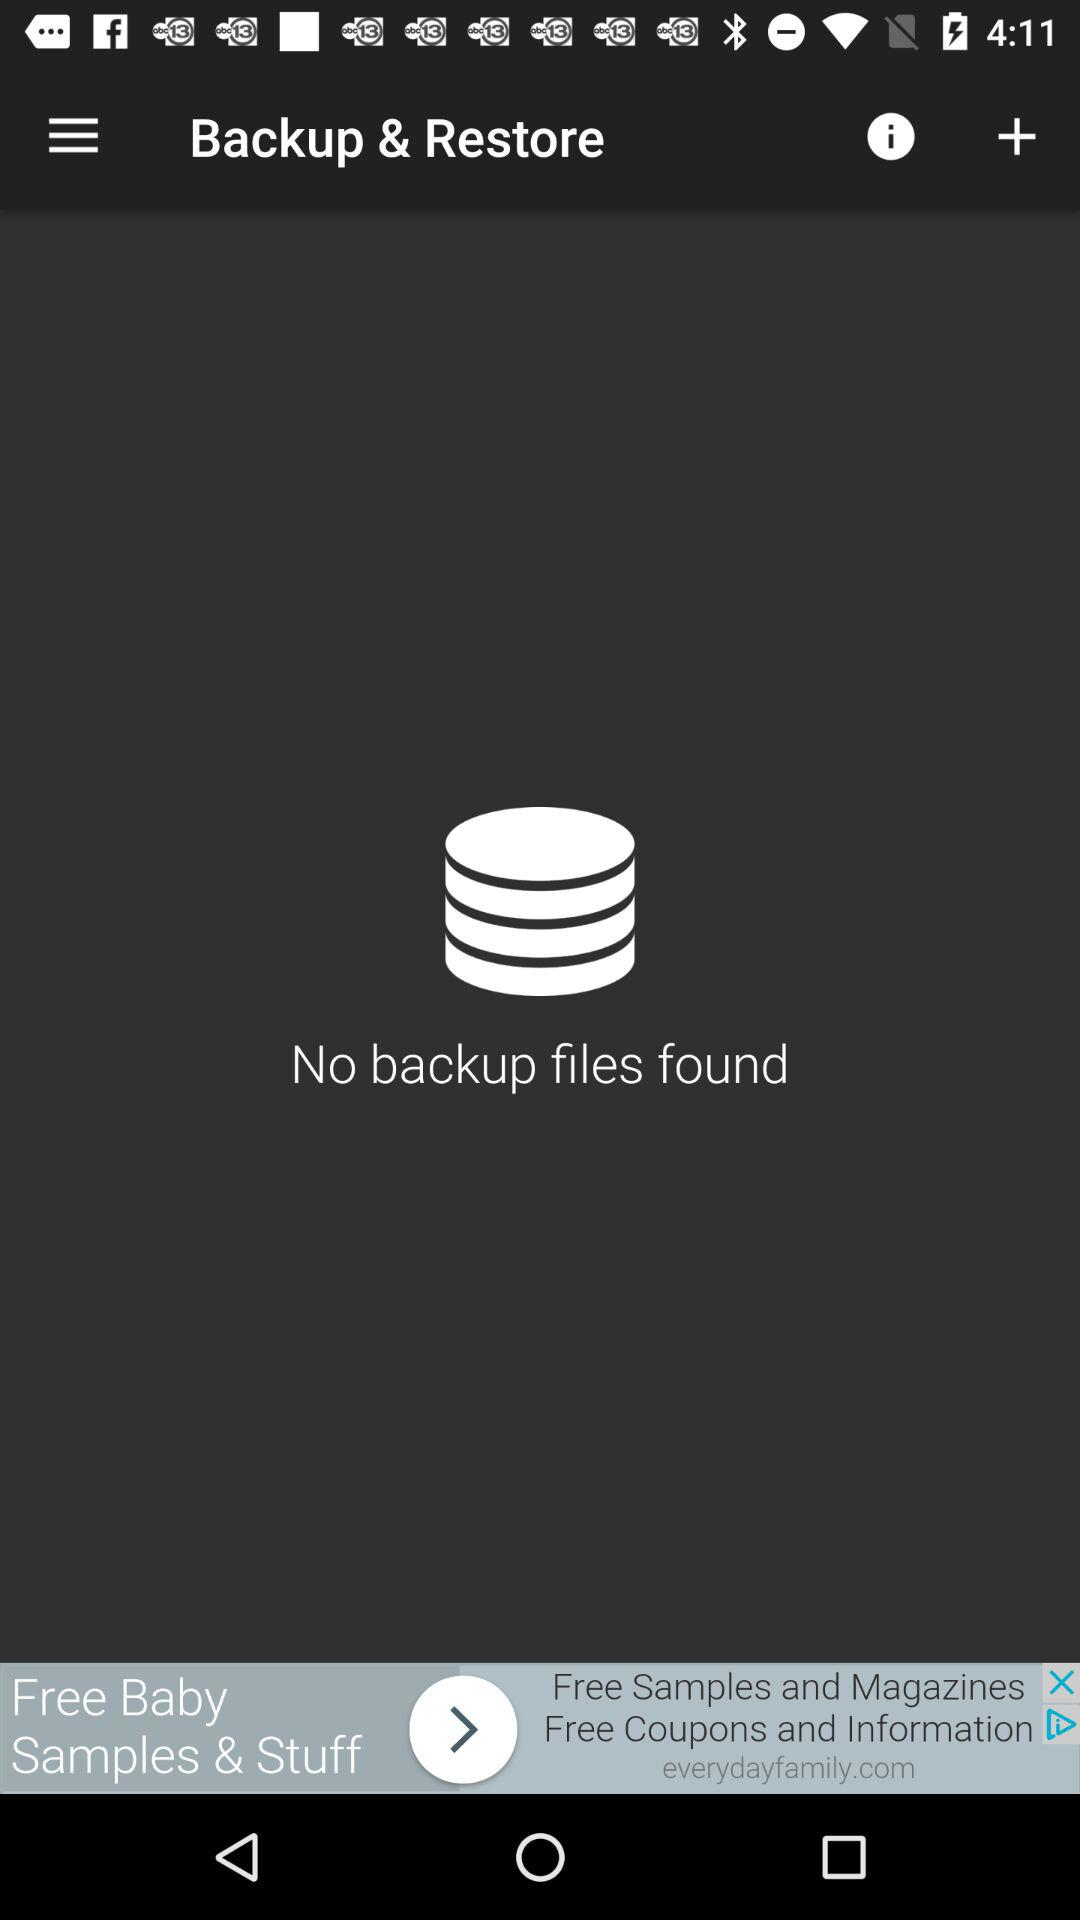Is there any backup file found? There is no backup file. 